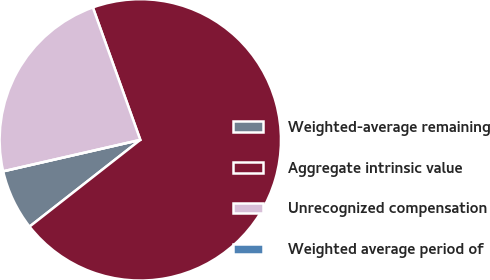Convert chart. <chart><loc_0><loc_0><loc_500><loc_500><pie_chart><fcel>Weighted-average remaining<fcel>Aggregate intrinsic value<fcel>Unrecognized compensation<fcel>Weighted average period of<nl><fcel>6.99%<fcel>69.9%<fcel>23.11%<fcel>0.0%<nl></chart> 